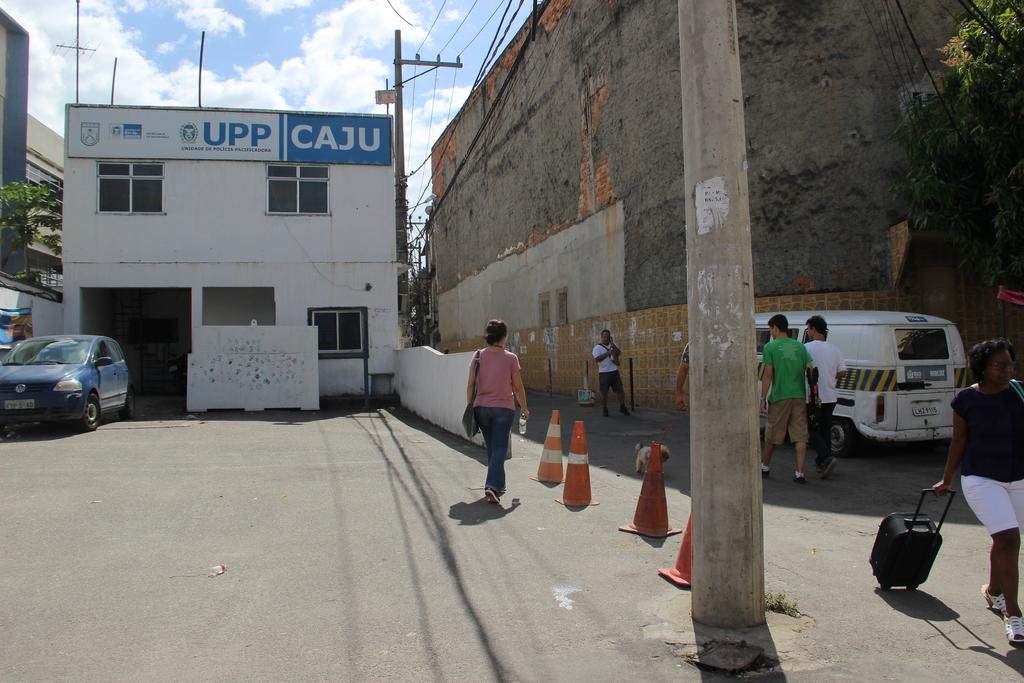<image>
Offer a succinct explanation of the picture presented. People walking around in front of the Upp Caju building 